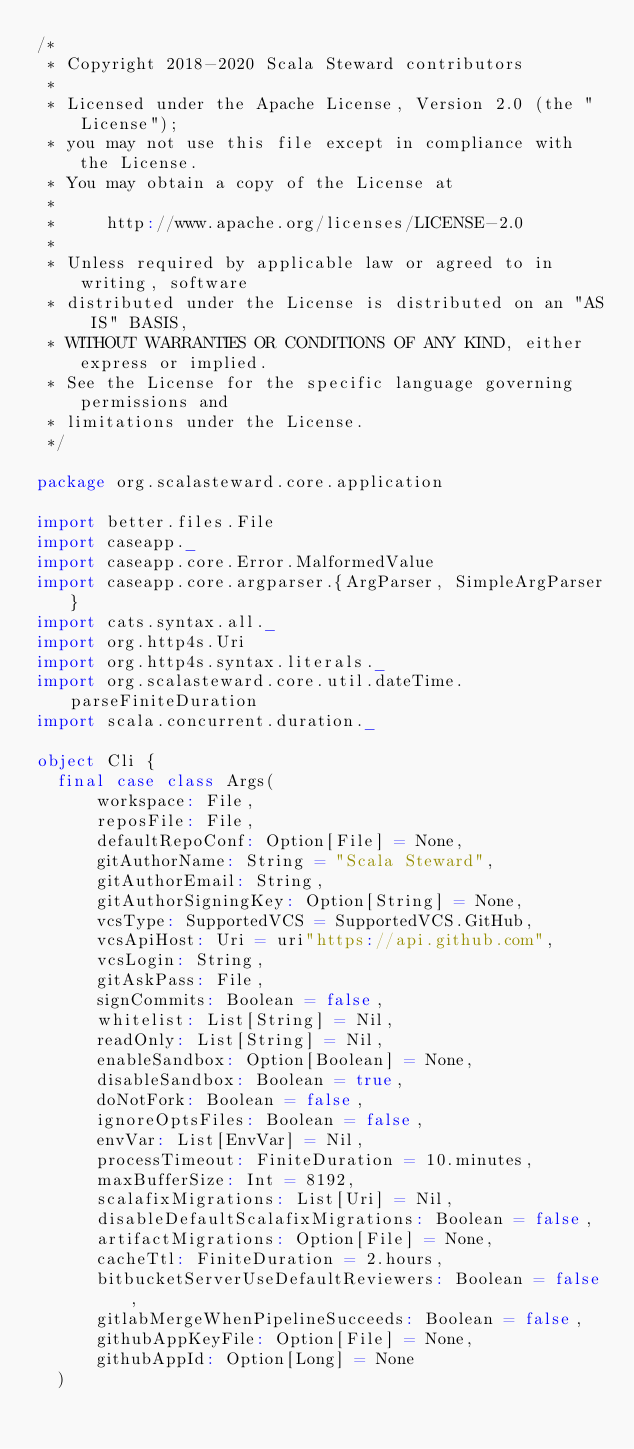<code> <loc_0><loc_0><loc_500><loc_500><_Scala_>/*
 * Copyright 2018-2020 Scala Steward contributors
 *
 * Licensed under the Apache License, Version 2.0 (the "License");
 * you may not use this file except in compliance with the License.
 * You may obtain a copy of the License at
 *
 *     http://www.apache.org/licenses/LICENSE-2.0
 *
 * Unless required by applicable law or agreed to in writing, software
 * distributed under the License is distributed on an "AS IS" BASIS,
 * WITHOUT WARRANTIES OR CONDITIONS OF ANY KIND, either express or implied.
 * See the License for the specific language governing permissions and
 * limitations under the License.
 */

package org.scalasteward.core.application

import better.files.File
import caseapp._
import caseapp.core.Error.MalformedValue
import caseapp.core.argparser.{ArgParser, SimpleArgParser}
import cats.syntax.all._
import org.http4s.Uri
import org.http4s.syntax.literals._
import org.scalasteward.core.util.dateTime.parseFiniteDuration
import scala.concurrent.duration._

object Cli {
  final case class Args(
      workspace: File,
      reposFile: File,
      defaultRepoConf: Option[File] = None,
      gitAuthorName: String = "Scala Steward",
      gitAuthorEmail: String,
      gitAuthorSigningKey: Option[String] = None,
      vcsType: SupportedVCS = SupportedVCS.GitHub,
      vcsApiHost: Uri = uri"https://api.github.com",
      vcsLogin: String,
      gitAskPass: File,
      signCommits: Boolean = false,
      whitelist: List[String] = Nil,
      readOnly: List[String] = Nil,
      enableSandbox: Option[Boolean] = None,
      disableSandbox: Boolean = true,
      doNotFork: Boolean = false,
      ignoreOptsFiles: Boolean = false,
      envVar: List[EnvVar] = Nil,
      processTimeout: FiniteDuration = 10.minutes,
      maxBufferSize: Int = 8192,
      scalafixMigrations: List[Uri] = Nil,
      disableDefaultScalafixMigrations: Boolean = false,
      artifactMigrations: Option[File] = None,
      cacheTtl: FiniteDuration = 2.hours,
      bitbucketServerUseDefaultReviewers: Boolean = false,
      gitlabMergeWhenPipelineSucceeds: Boolean = false,
      githubAppKeyFile: Option[File] = None,
      githubAppId: Option[Long] = None
  )
</code> 